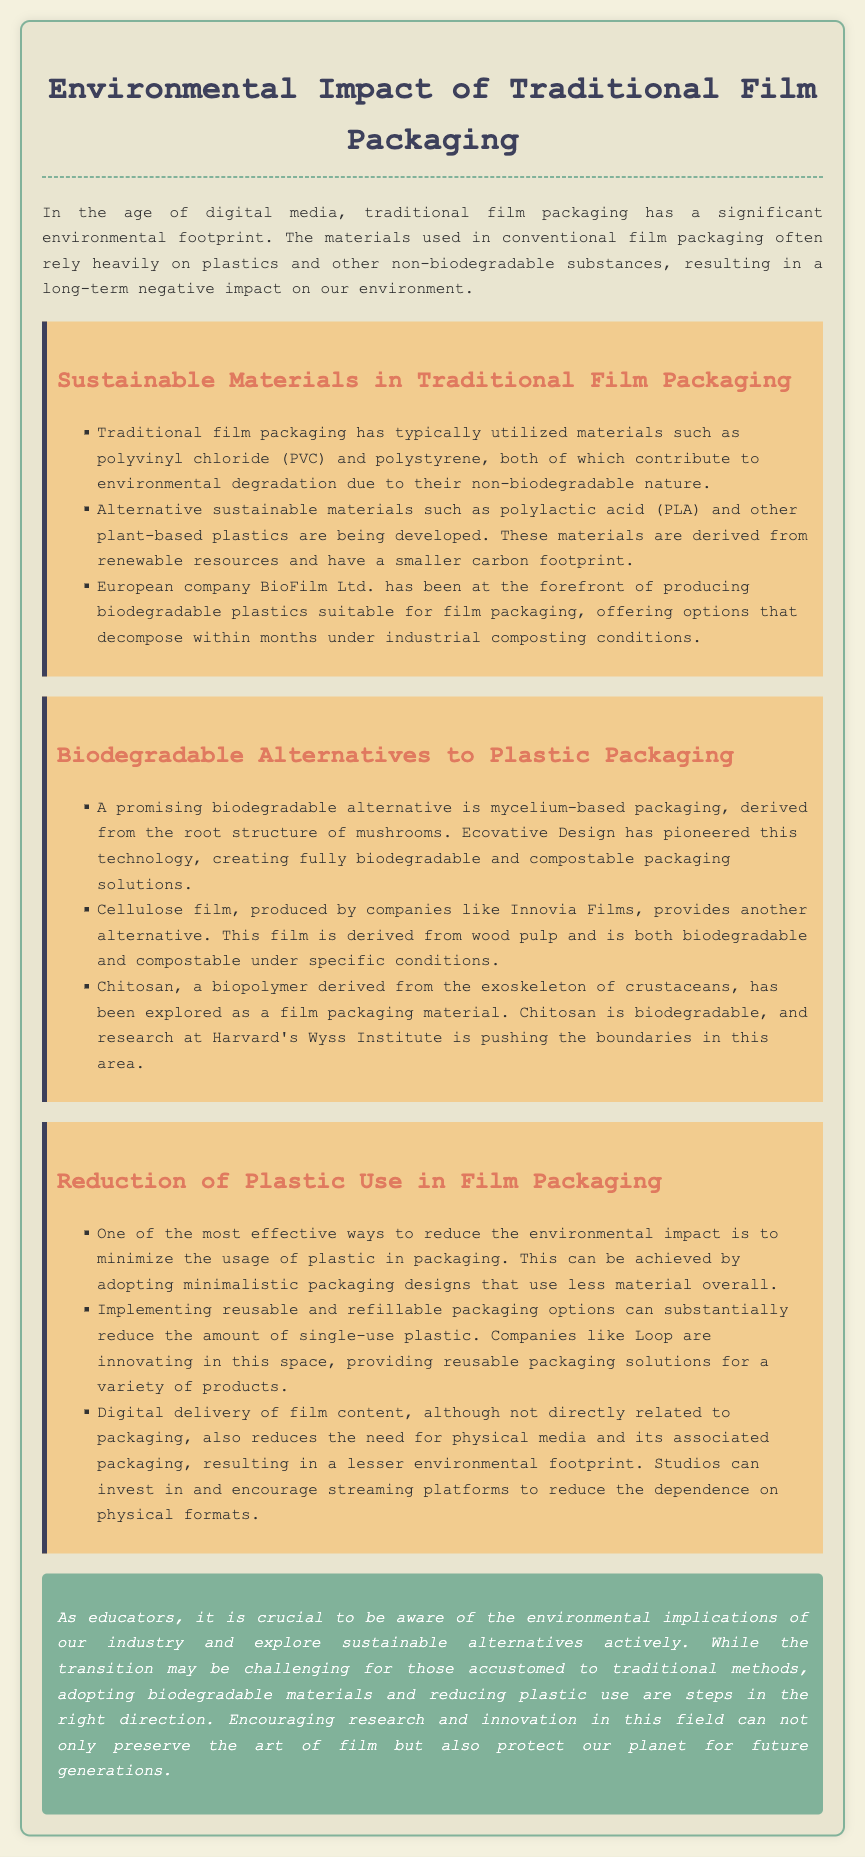What materials are typically used in traditional film packaging? The document states that traditional film packaging has utilized materials such as polyvinyl chloride (PVC) and polystyrene.
Answer: PVC and polystyrene What is a promising biodegradable alternative to plastic packaging? The document mentions mycelium-based packaging as a promising biodegradable alternative.
Answer: Mycelium-based packaging Which company produces biodegradable plastics suitable for film packaging? The document identifies BioFilm Ltd. as a company that produces biodegradable plastics suitable for film packaging.
Answer: BioFilm Ltd What is a benefit of cellulose film mentioned in the document? The document states that cellulose film is both biodegradable and compostable under specific conditions.
Answer: Biodegradable and compostable What strategy can minimize the usage of plastic in film packaging? The document suggests adopting minimalistic packaging designs that use less material overall as a strategy to minimize plastic use.
Answer: Minimalistic packaging designs How can reusable packaging options help the environment? The document explains that implementing reusable and refillable packaging options can substantially reduce the amount of single-use plastic.
Answer: Reduce single-use plastic What is the role of digital delivery in reducing environmental impact? According to the document, digital delivery reduces the need for physical media and its associated packaging, resulting in a lesser environmental footprint.
Answer: Lesser environmental footprint What is emphasized as important for educators regarding the film industry? The document emphasizes that it is crucial for educators to be aware of the environmental implications of the industry.
Answer: Awareness of environmental implications 